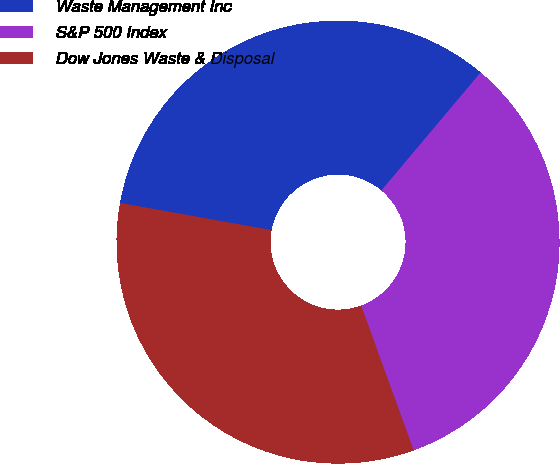Convert chart. <chart><loc_0><loc_0><loc_500><loc_500><pie_chart><fcel>Waste Management Inc<fcel>S&P 500 Index<fcel>Dow Jones Waste & Disposal<nl><fcel>33.3%<fcel>33.33%<fcel>33.37%<nl></chart> 